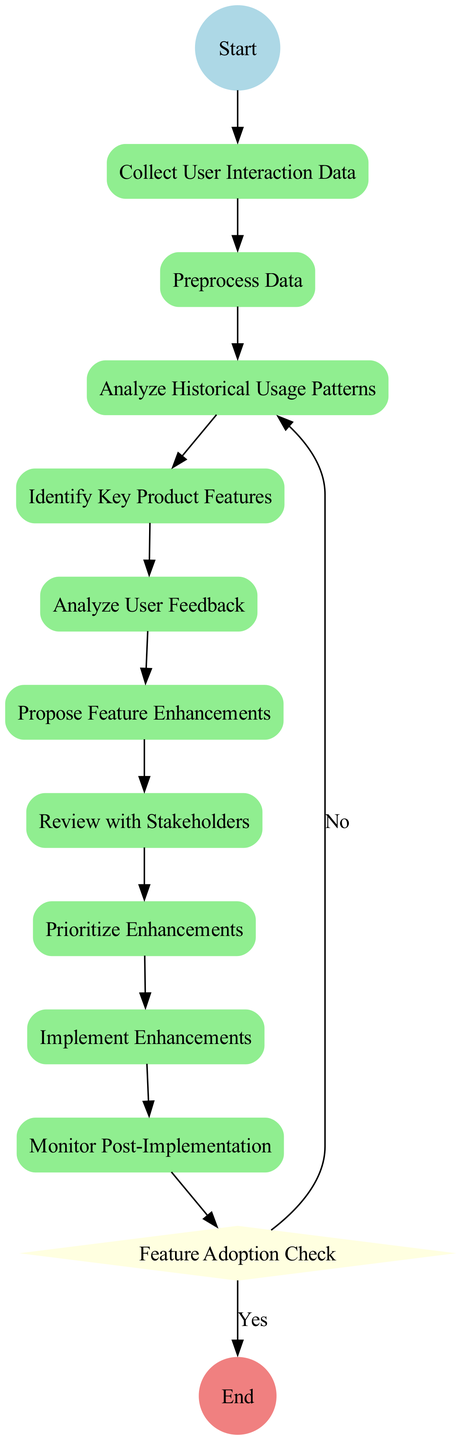What is the first activity in the diagram? The first activity is the first node connected to the 'Start' node in the flow, which is 'Collect User Interaction Data'.
Answer: Collect User Interaction Data What is the last activity in the diagram? The last activity is the final node before reaching the 'End' node, which is 'Monitor Post-Implementation'.
Answer: Monitor Post-Implementation How many activities are there in total? By counting the number of activity nodes in the diagram, there are ten activities listed.
Answer: Ten What decision point is present in the diagram? The decision point is the diamond-shaped node that indicates a choice must be made, which is 'Feature Adoption Check'.
Answer: Feature Adoption Check What activity directly follows 'Analyze User Feedback'? Following the flow from 'Analyze User Feedback', the next activity is 'Propose Feature Enhancements'.
Answer: Propose Feature Enhancements What happens if users adopt the new features? If users adopt the new features, the flow leads directly to the 'End' node without further actions.
Answer: End How many edges connect the activities? Counting the edges that connect each sequential activity, there are nine edges in total.
Answer: Nine Which activity determines the priority of enhancements? The activity that determines the priority is directly connected to the previously analyzed features, which is 'Prioritize Enhancements'.
Answer: Prioritize Enhancements What type of diagram is being presented here? The diagram type can be identified by its representation of activities and decision points in a process, specifically an 'Activity Diagram'.
Answer: Activity Diagram 